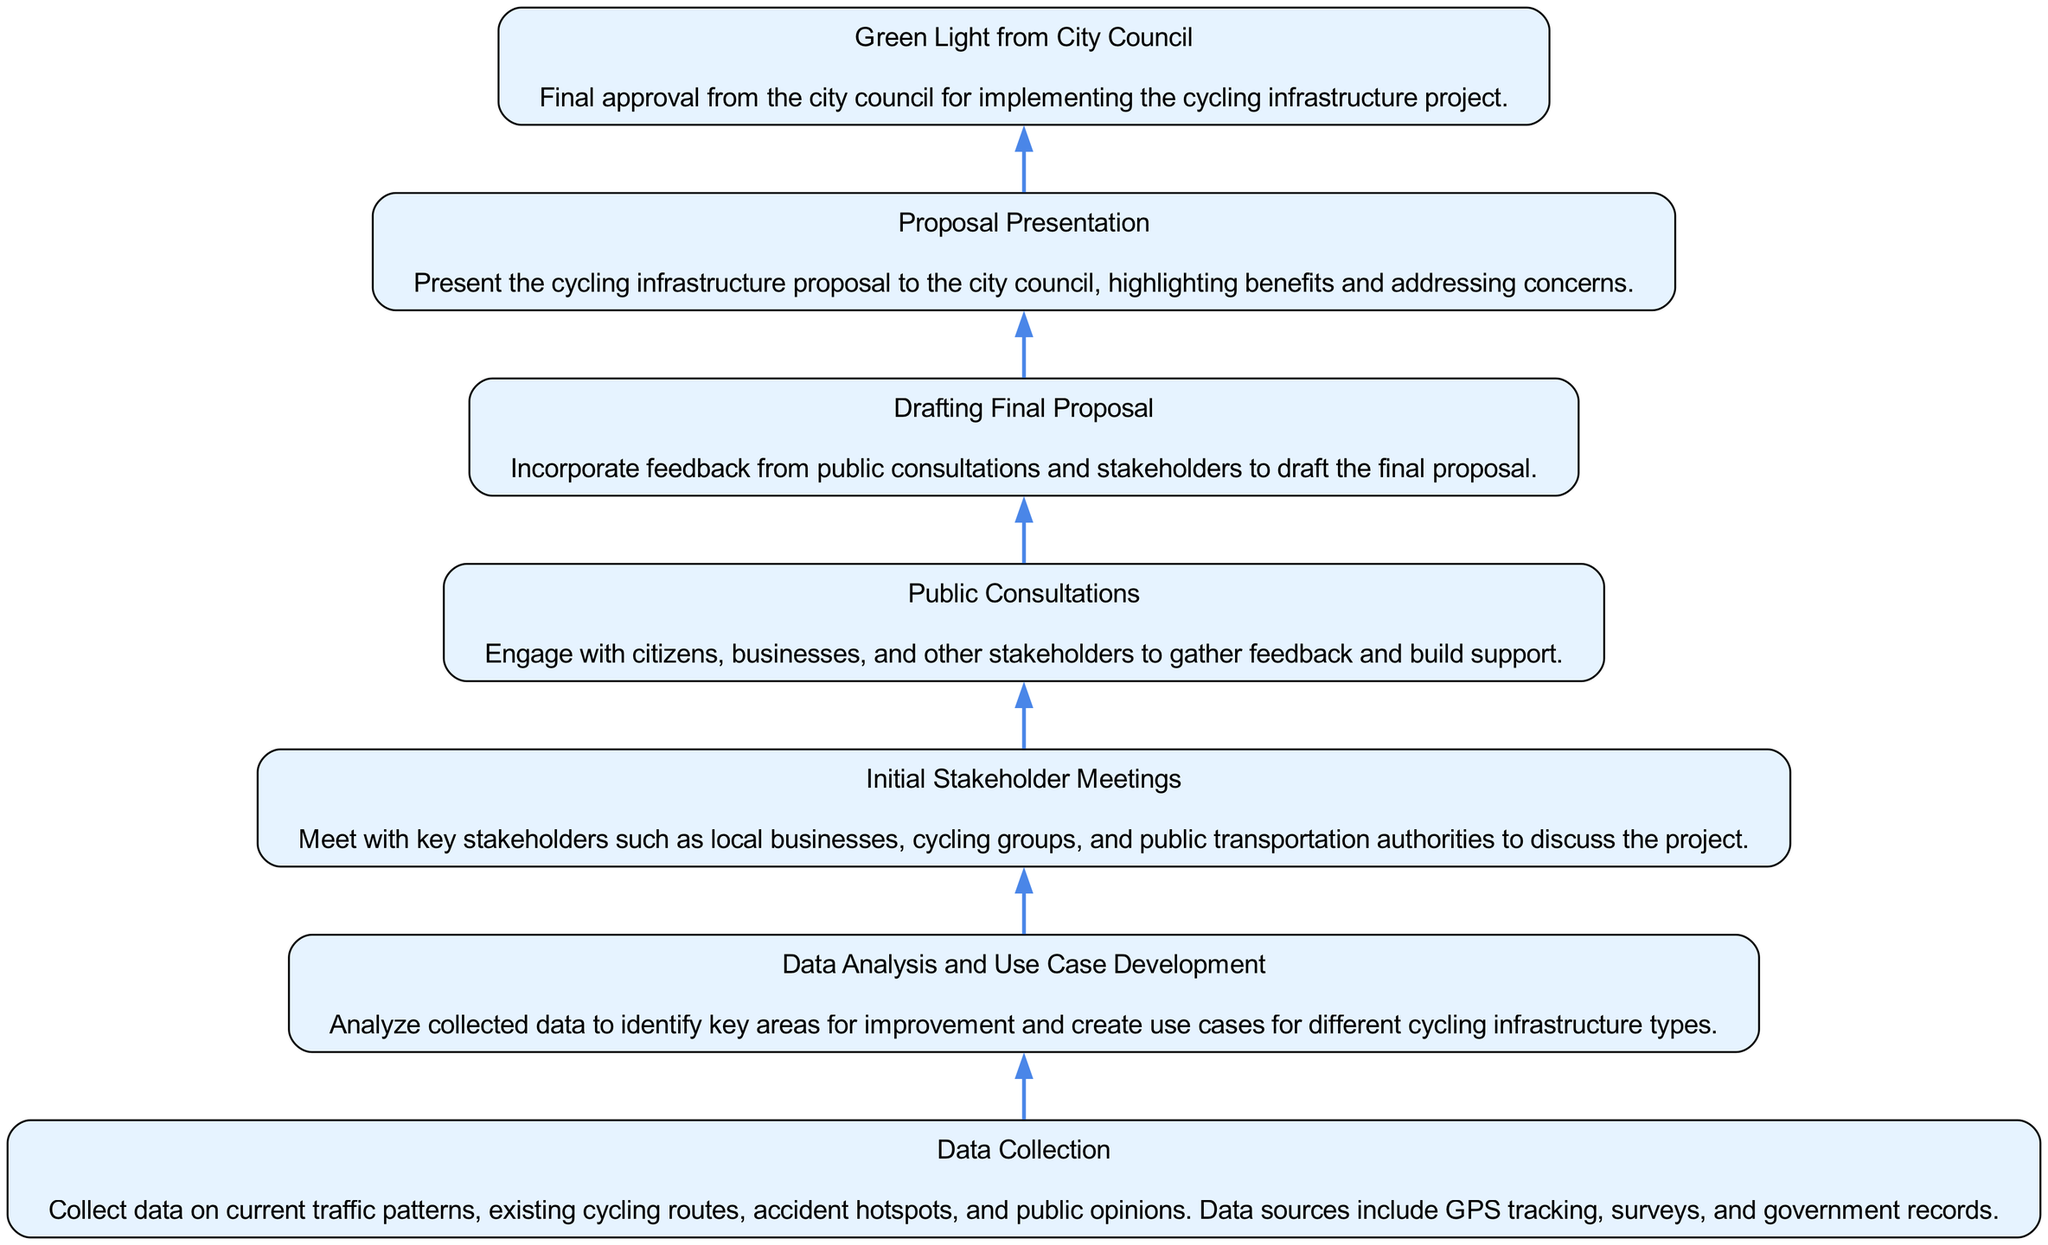What is the final step in the diagram? The final step in the diagram is "Green Light from City Council", which represents the approval required to move forward with the cycling infrastructure project.
Answer: Green Light from City Council How many elements are in the diagram? The diagram contains a total of 7 elements representing distinct stages in the process of integrating cycling infrastructure.
Answer: 7 Which step comes before "Drafting Final Proposal"? "Public Consultations" is the step that comes immediately before "Drafting Final Proposal" in the flow of the diagram.
Answer: Public Consultations What is the starting point of the flow? The flow starts with "Data Collection", which is the initial step for gathering necessary information before further actions can be taken.
Answer: Data Collection Which element discusses stakeholder involvement? "Initial Stakeholder Meetings" specifically addresses the involvement of key stakeholders in discussing the cycling infrastructure project.
Answer: Initial Stakeholder Meetings What is the purpose of "Data Analysis and Use Case Development"? The purpose of "Data Analysis and Use Case Development" is to analyze the collected data to spot key improvement areas and create use cases for different infrastructure types.
Answer: Analyze collected data What is the relationship between "Public Consultations" and "Drafting Final Proposal"? "Public Consultations" provides feedback that is used in "Drafting Final Proposal", indicating that input from consultations directly influences the final proposal draft.
Answer: Feedback incorporation What action is represented immediately after "Data Collection"? The action represented immediately after "Data Collection" is "Data Analysis and Use Case Development", indicating the next step of analyzing the information gathered.
Answer: Data Analysis and Use Case Development Which step is concerned with presenting the final project to the authority? "Proposal Presentation" is the step concerned with presenting the proposed cycling infrastructure project to the city council.
Answer: Proposal Presentation 